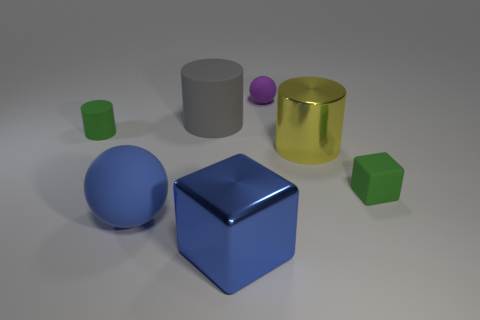The sphere on the left side of the big block is what color? The sphere located to the left of the large blue block exhibits a deep blue hue, consistent in color with the block itself, yet distinct in shape, presenting a smooth and unadorned spherical surface. 